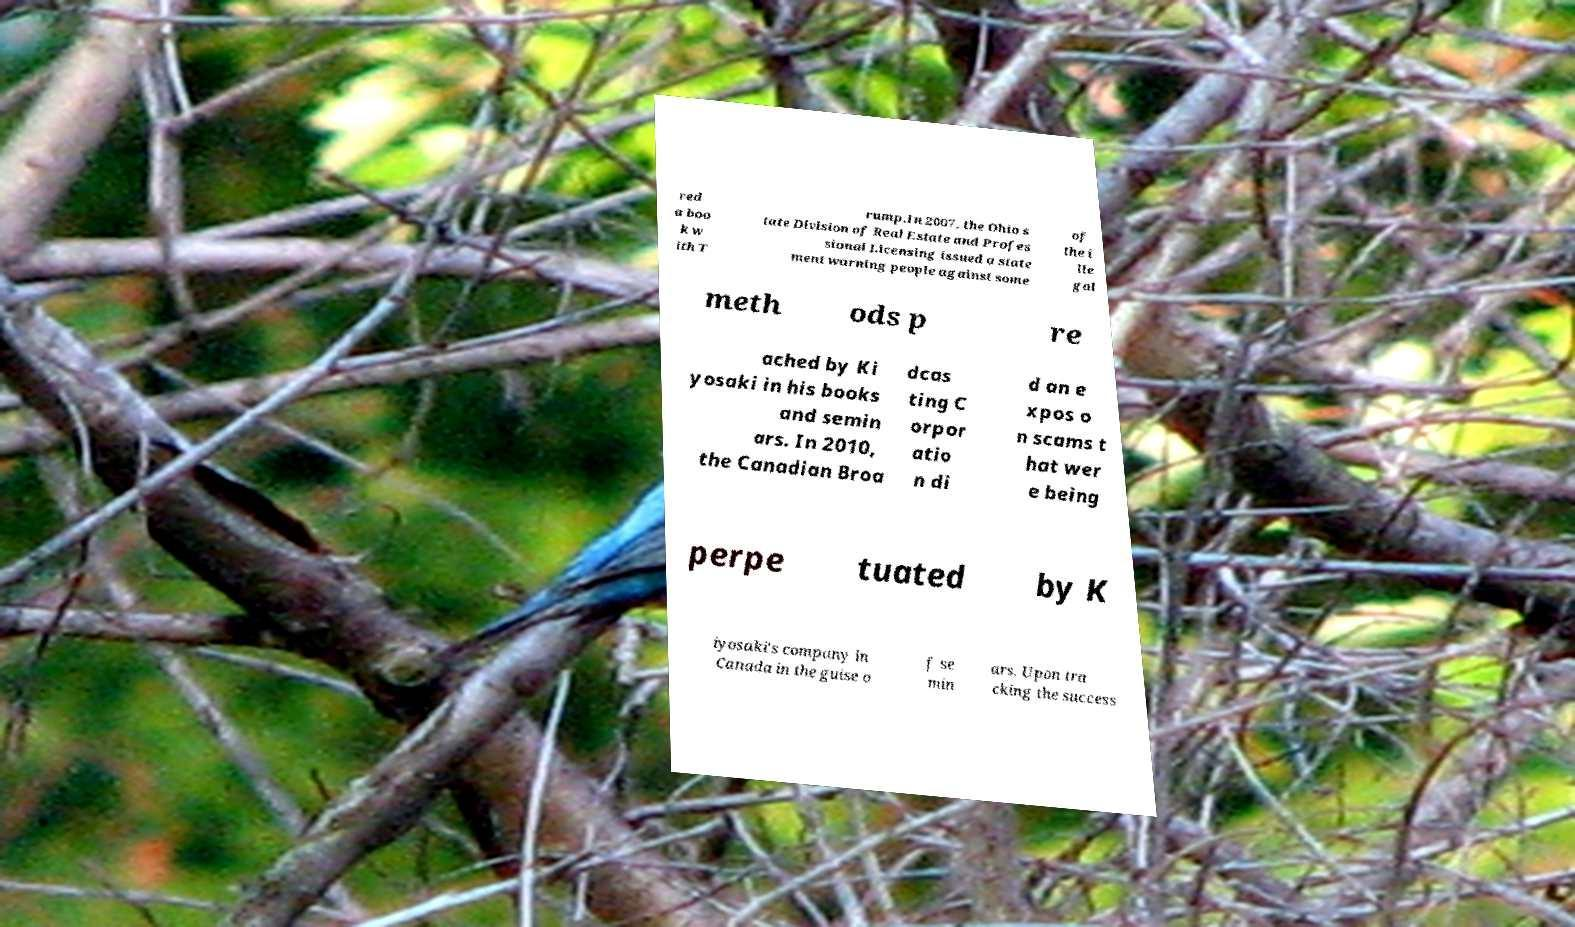Could you assist in decoding the text presented in this image and type it out clearly? red a boo k w ith T rump.In 2007, the Ohio s tate Division of Real Estate and Profes sional Licensing issued a state ment warning people against some of the i lle gal meth ods p re ached by Ki yosaki in his books and semin ars. In 2010, the Canadian Broa dcas ting C orpor atio n di d an e xpos o n scams t hat wer e being perpe tuated by K iyosaki's company in Canada in the guise o f se min ars. Upon tra cking the success 